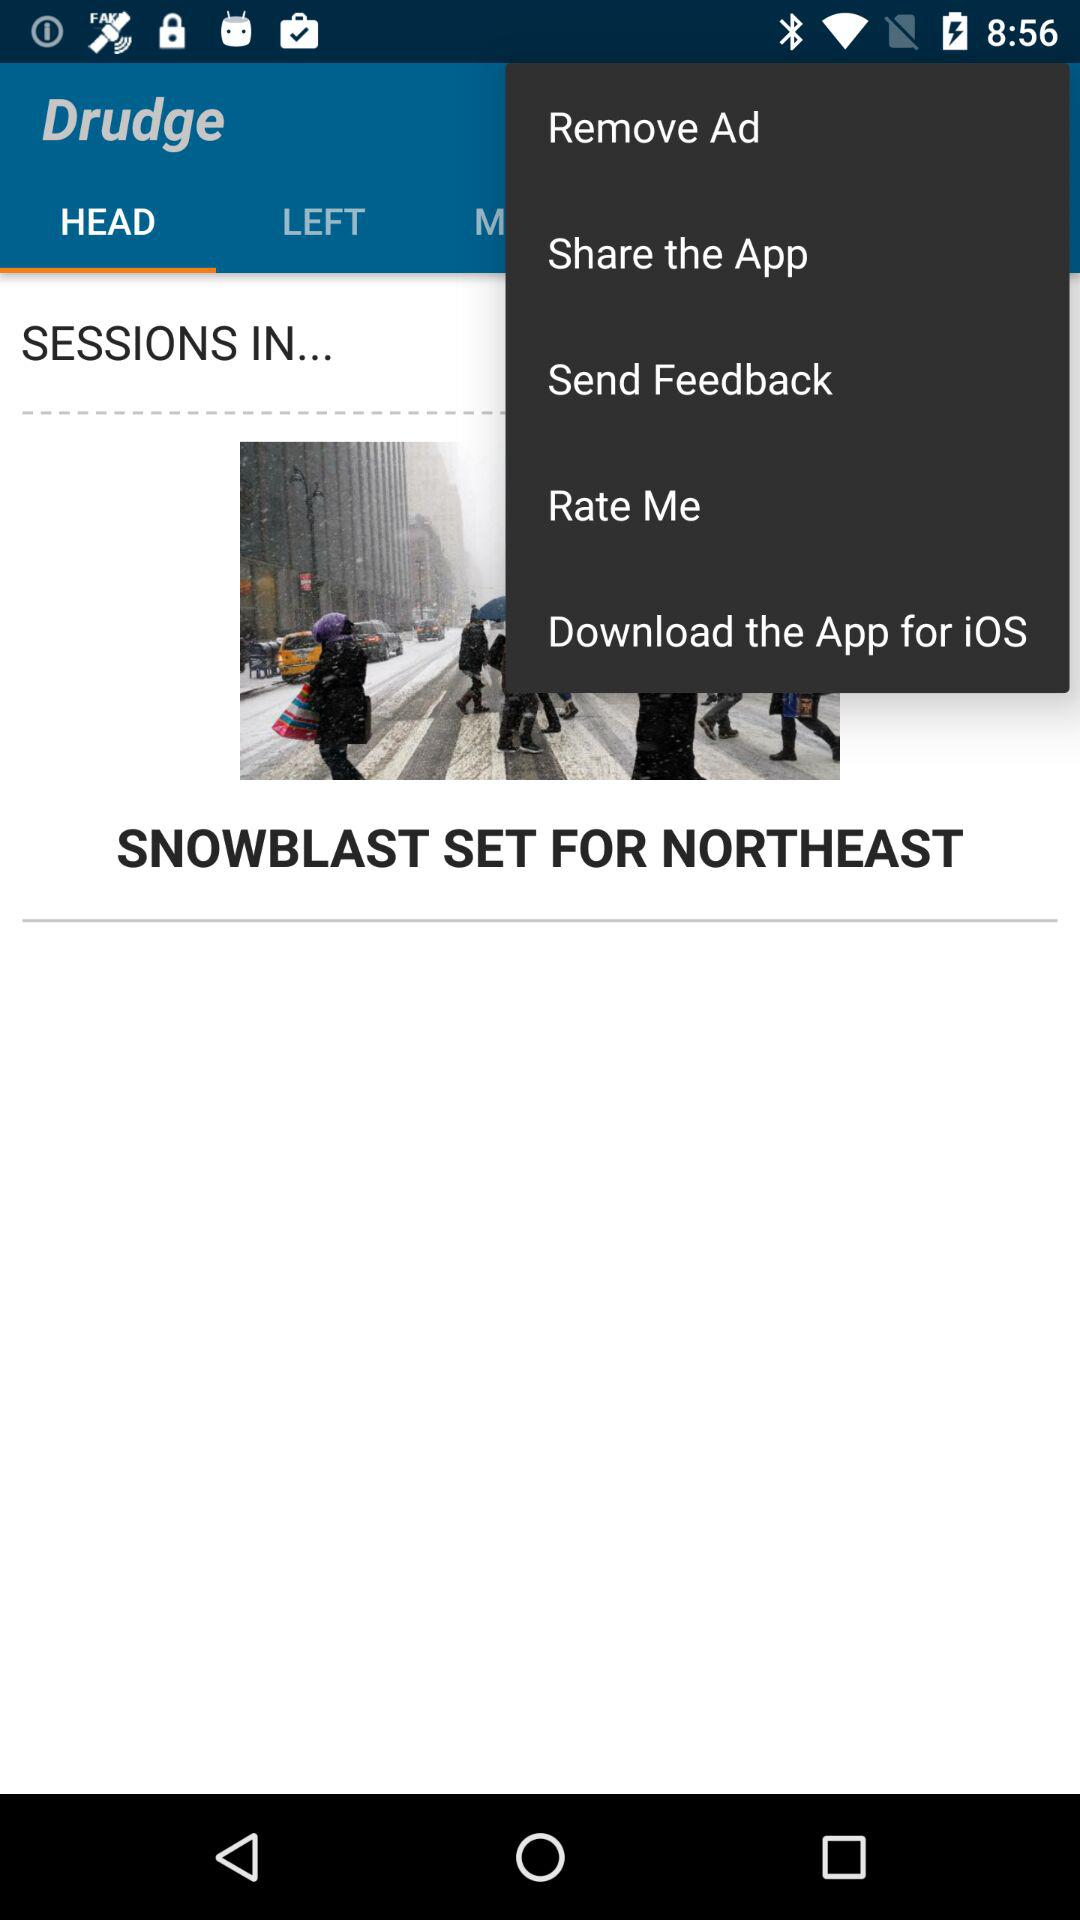What is the application name? The application name is "Drudge". 